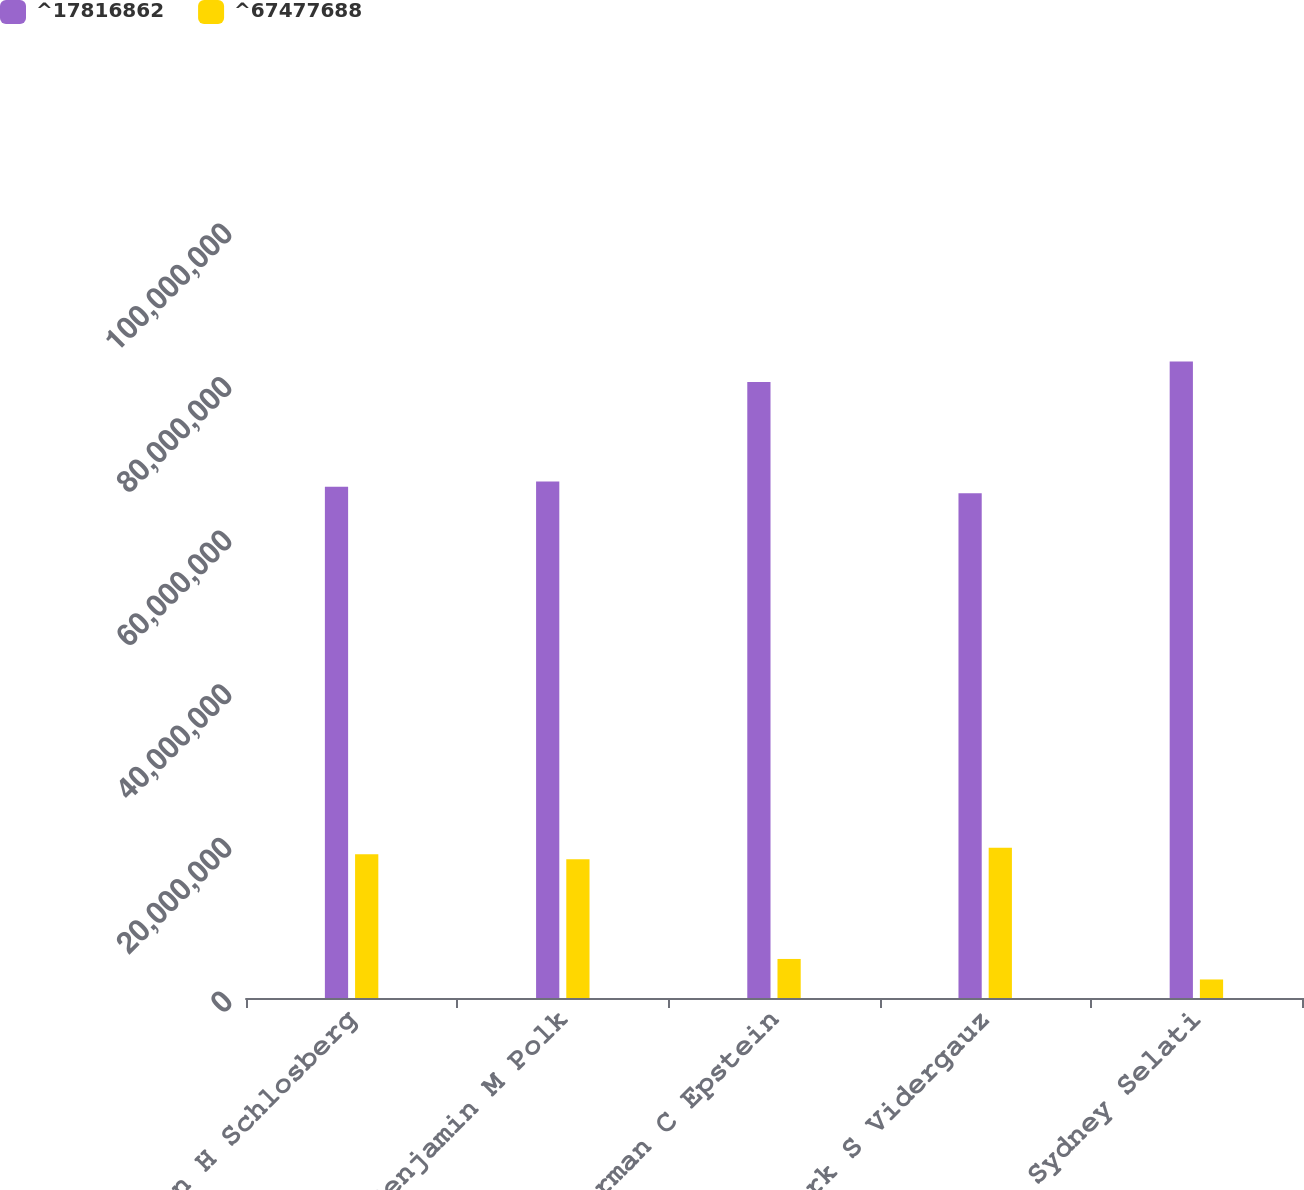Convert chart to OTSL. <chart><loc_0><loc_0><loc_500><loc_500><stacked_bar_chart><ecel><fcel>Hilton H Schlosberg<fcel>Benjamin M Polk<fcel>Norman C Epstein<fcel>Mark S Vidergauz<fcel>Sydney Selati<nl><fcel>^17816862<fcel>6.65704e+07<fcel>6.7241e+07<fcel>8.02102e+07<fcel>6.57203e+07<fcel>8.28813e+07<nl><fcel>^67477688<fcel>1.87241e+07<fcel>1.80536e+07<fcel>5.08437e+06<fcel>1.95742e+07<fcel>2.41326e+06<nl></chart> 